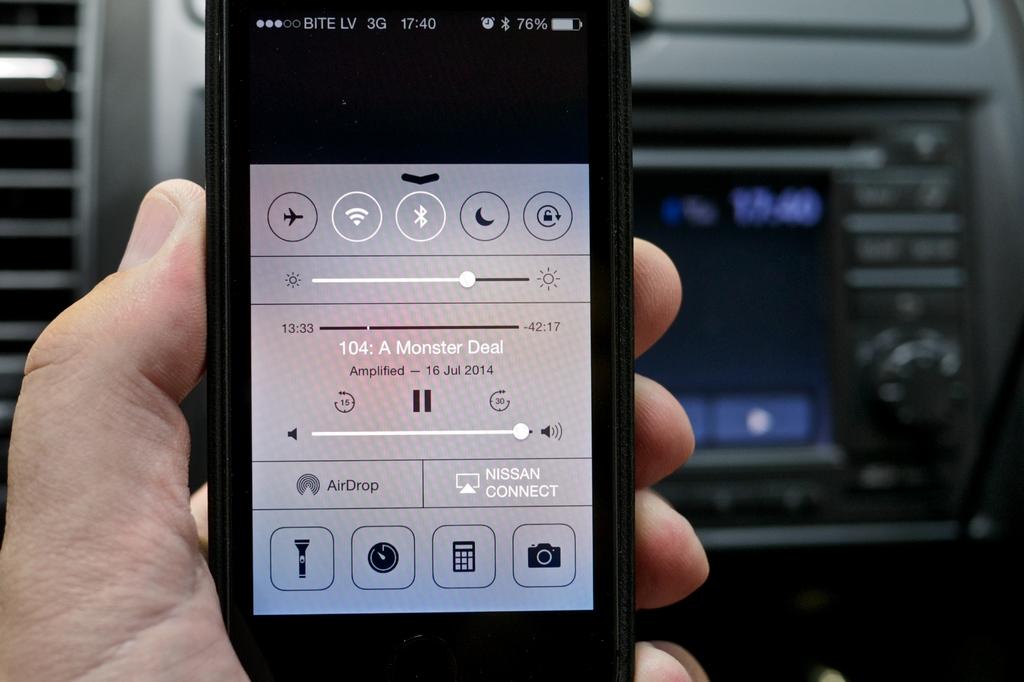What is the battery percentage of the phone?
Make the answer very short. 76. 